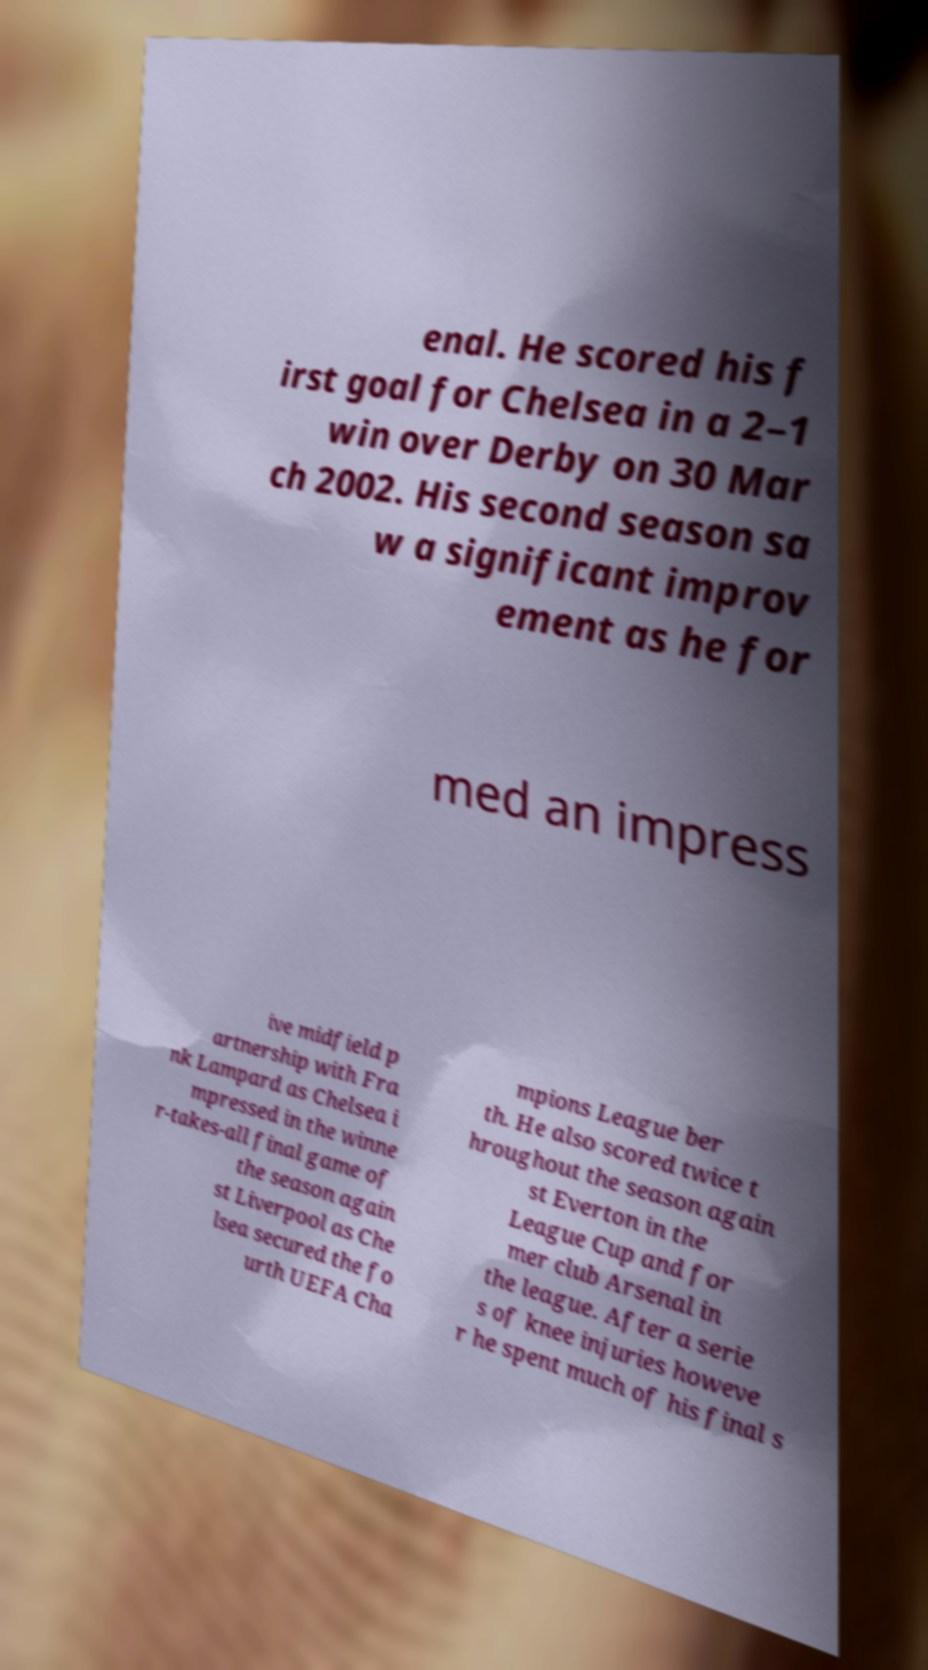Please identify and transcribe the text found in this image. enal. He scored his f irst goal for Chelsea in a 2–1 win over Derby on 30 Mar ch 2002. His second season sa w a significant improv ement as he for med an impress ive midfield p artnership with Fra nk Lampard as Chelsea i mpressed in the winne r-takes-all final game of the season again st Liverpool as Che lsea secured the fo urth UEFA Cha mpions League ber th. He also scored twice t hroughout the season again st Everton in the League Cup and for mer club Arsenal in the league. After a serie s of knee injuries howeve r he spent much of his final s 